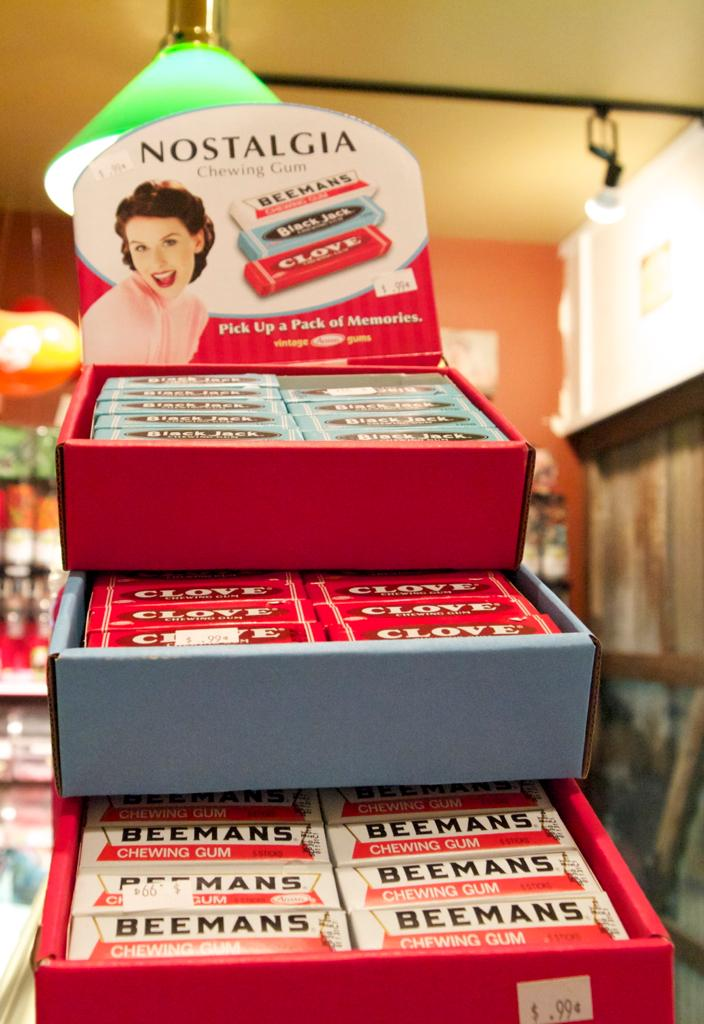Provide a one-sentence caption for the provided image. Various gum flavors from Nostalgia priced 99 cents. 